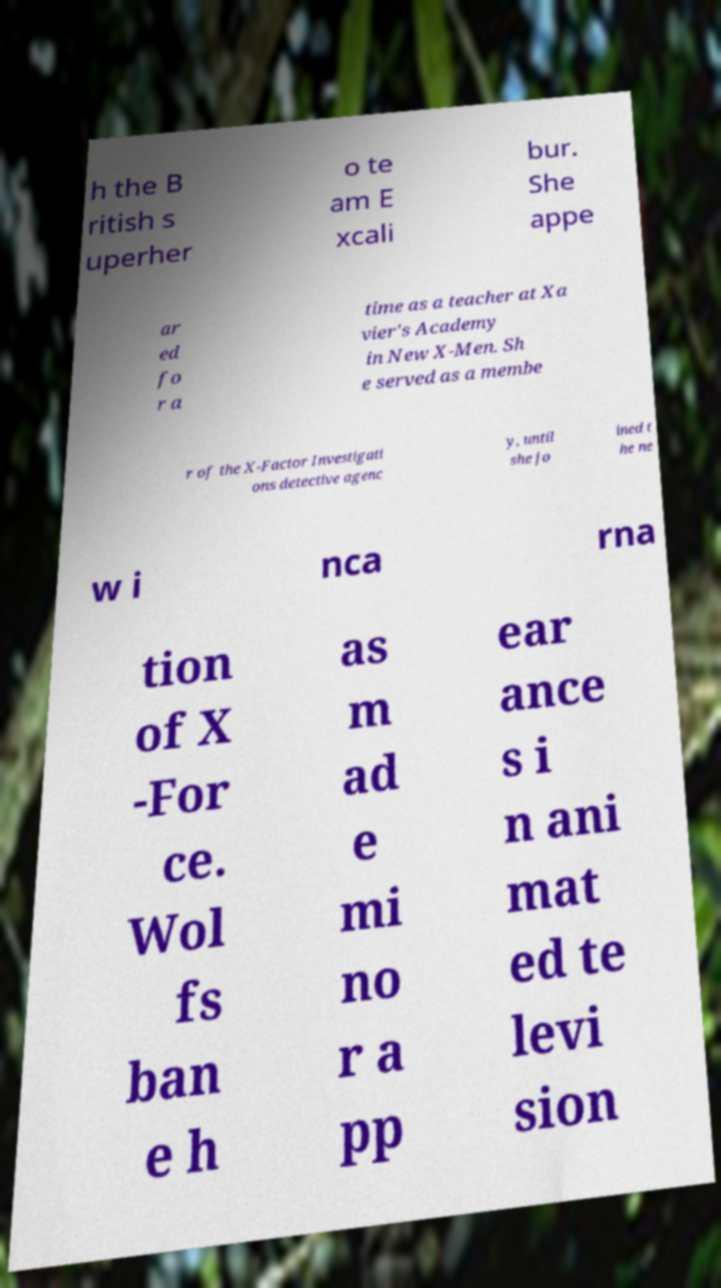Could you assist in decoding the text presented in this image and type it out clearly? h the B ritish s uperher o te am E xcali bur. She appe ar ed fo r a time as a teacher at Xa vier's Academy in New X-Men. Sh e served as a membe r of the X-Factor Investigati ons detective agenc y, until she jo ined t he ne w i nca rna tion of X -For ce. Wol fs ban e h as m ad e mi no r a pp ear ance s i n ani mat ed te levi sion 